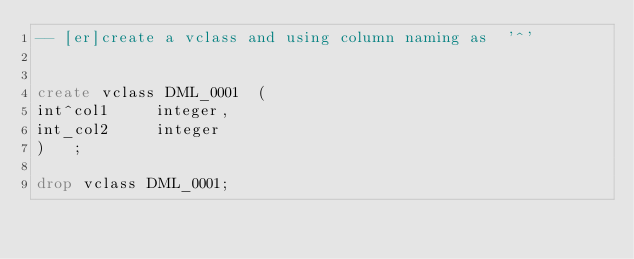Convert code to text. <code><loc_0><loc_0><loc_500><loc_500><_SQL_>-- [er]create a vclass and using column naming as  '^'


create vclass DML_0001 	( 
int^col1	 integer,
int_col2	 integer
)	;

drop vclass DML_0001;
</code> 